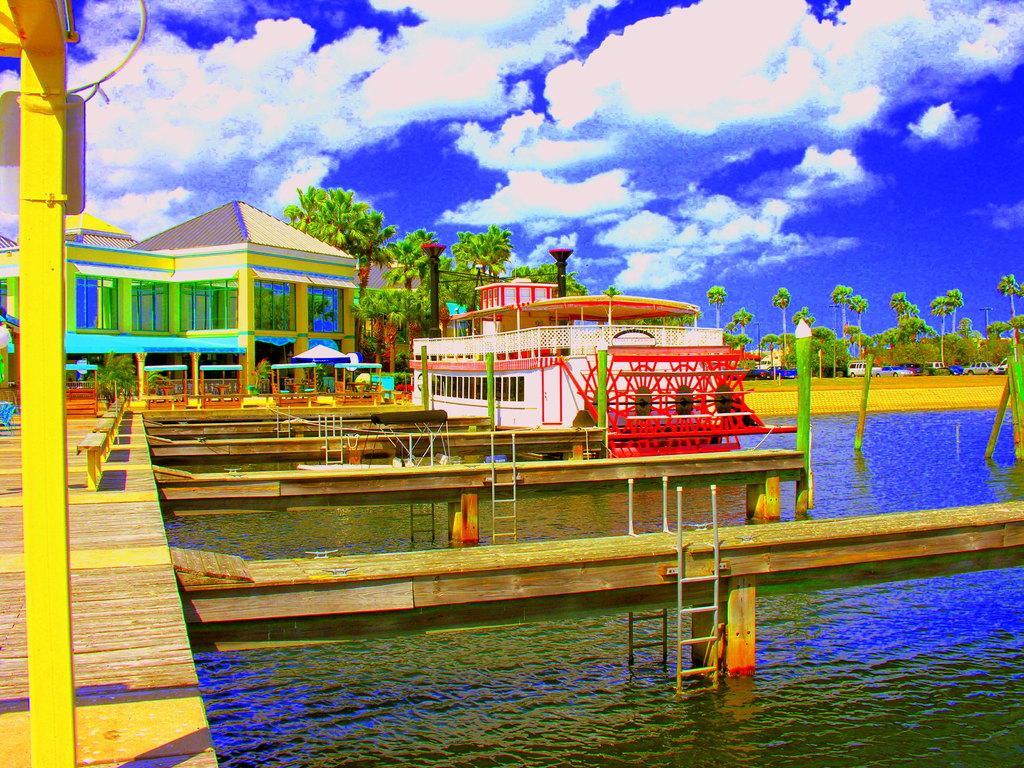How would you summarize this image in a sentence or two? In this image I can see a white colour boat on the water. I can also see number of poles, the platforms, ladders and on the left side of the image I can see few benches. In the background I can see number of trees, few plants, a building, clouds and the sky. 